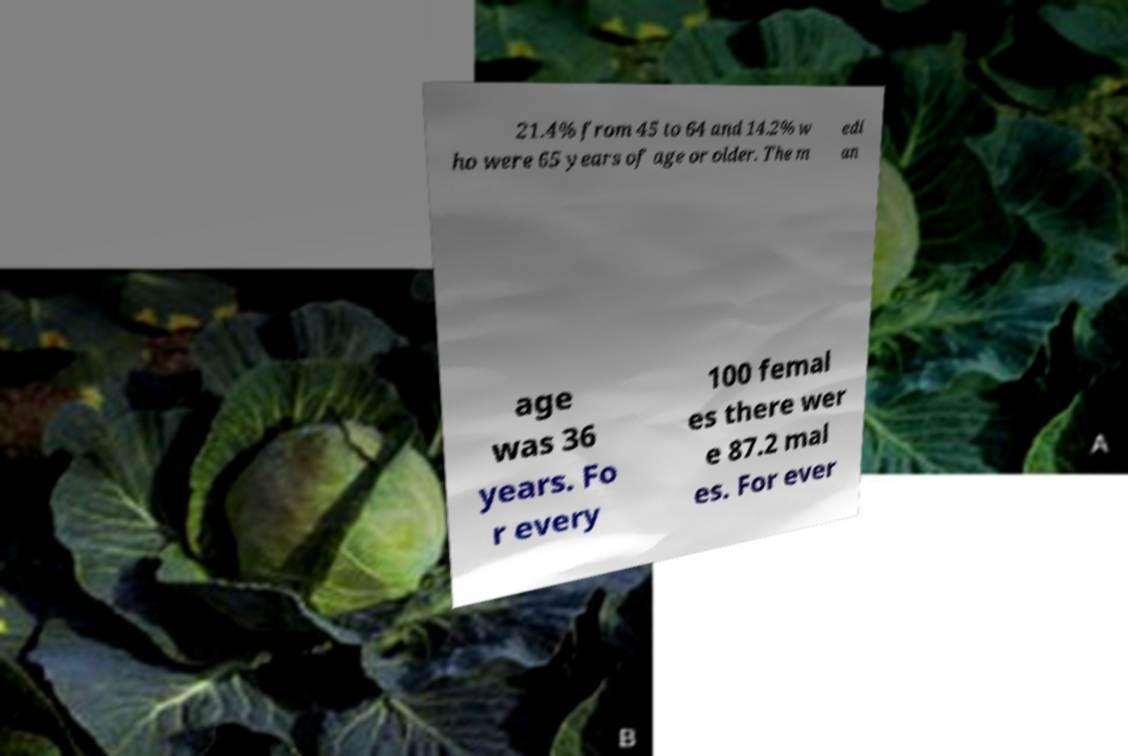There's text embedded in this image that I need extracted. Can you transcribe it verbatim? 21.4% from 45 to 64 and 14.2% w ho were 65 years of age or older. The m edi an age was 36 years. Fo r every 100 femal es there wer e 87.2 mal es. For ever 